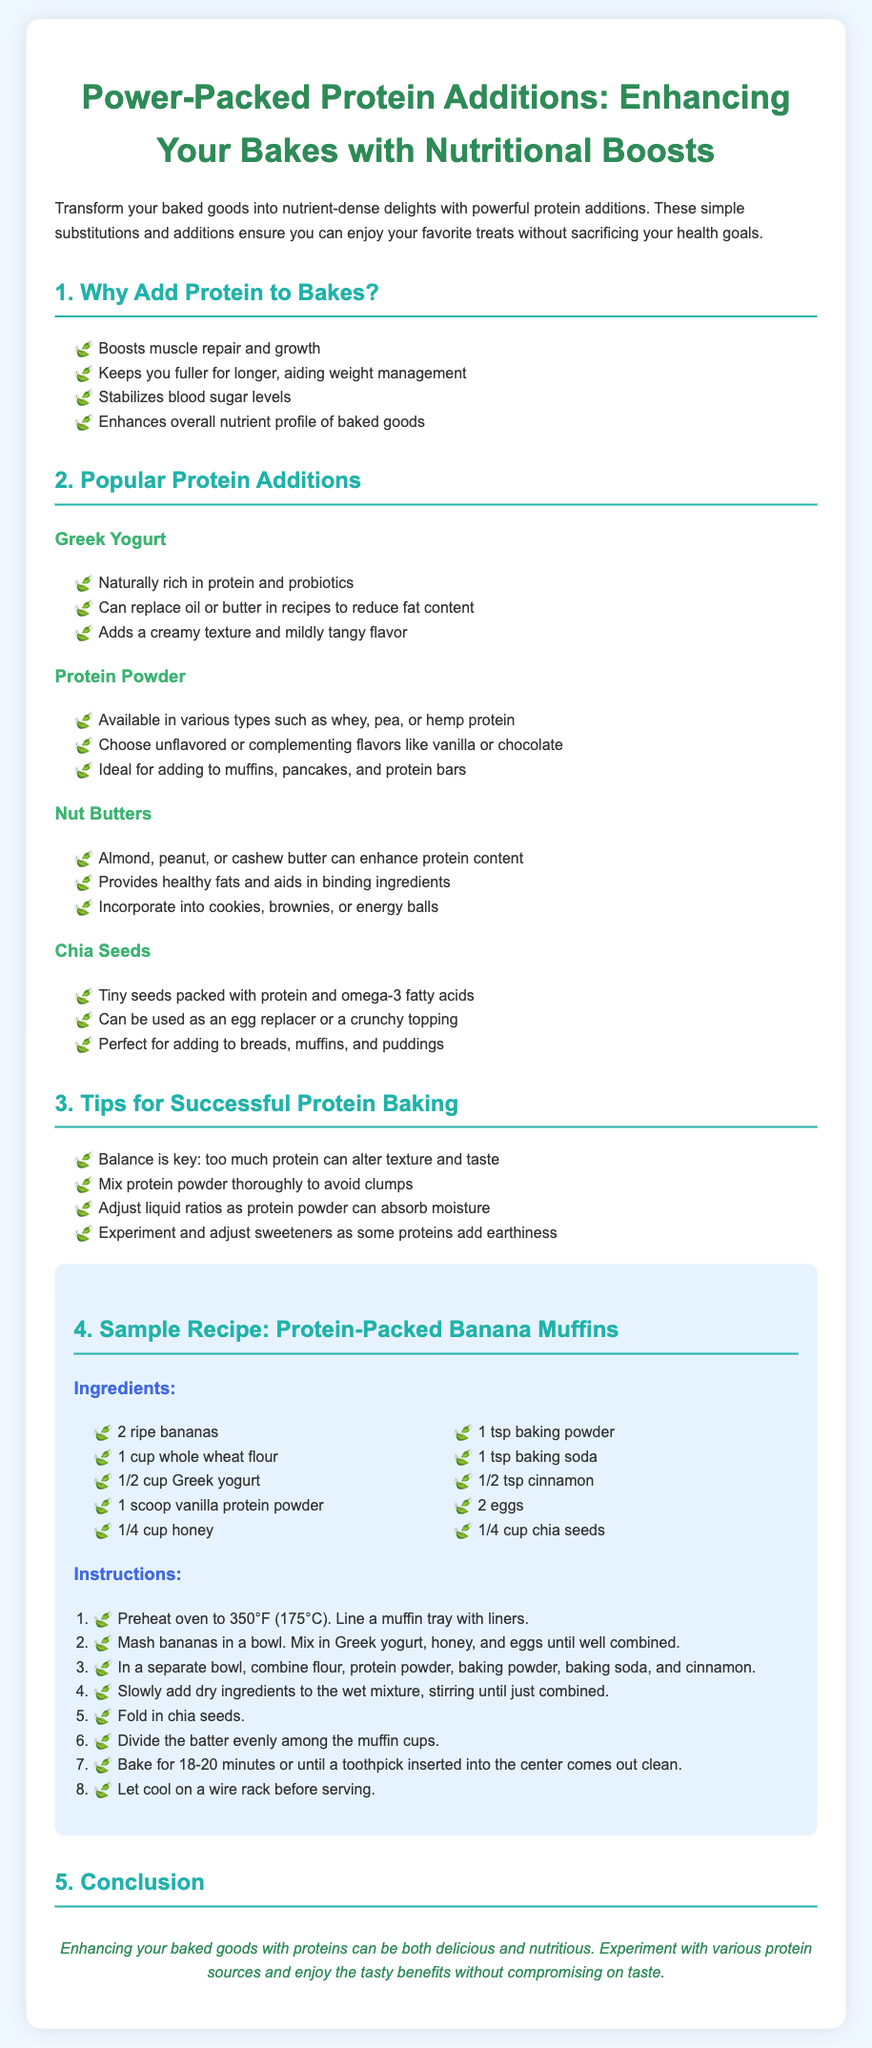What is the main purpose of adding protein to baked goods? The document states that adding protein helps with muscle repair, keeps you fuller, stabilizes blood sugar, and enhances the nutrient profile.
Answer: Nutritional benefits What is one popular protein addition mentioned? The document lists several, including Greek yogurt, protein powder, nut butters, and chia seeds.
Answer: Greek yogurt How many ingredients are in the sample recipe for Protein-Packed Banana Muffins? The document provides a list of ingredients for the sample recipe.
Answer: Ten ingredients What temperature should the oven be preheated to for the muffins? The instructions in the recipe specify the preheating temperature for the oven.
Answer: 350°F What is an important tip for successful protein baking? The document advises that balance is key and too much protein can affect texture and taste.
Answer: Balance is key What flavor of protein powder is suggested in the document? The document mentions vanilla protein powder as a complementing flavor.
Answer: Vanilla What type of flour is used in the Protein-Packed Banana Muffins recipe? The recipe specifies the type of flour used in the muffin batter.
Answer: Whole wheat flour What is the final step before serving the muffins? The instructions state to let the muffins cool on a wire rack after baking.
Answer: Let cool on a wire rack 